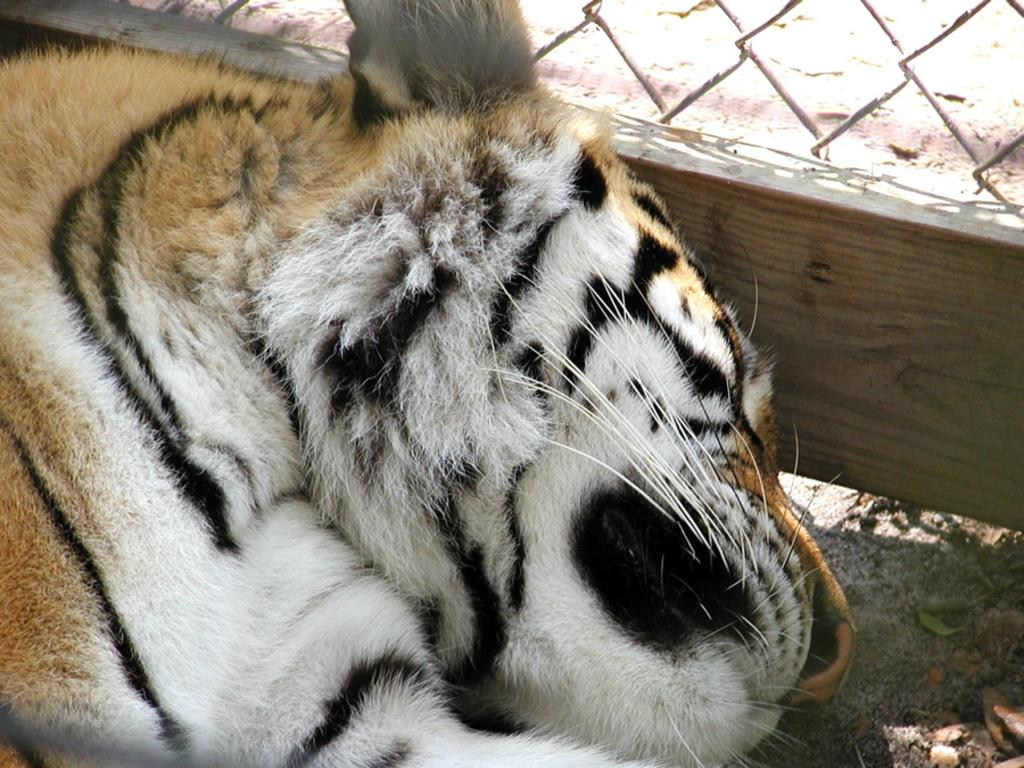What animal can be seen in the image? There is a tiger in the image. What is the tiger doing in the image? The tiger is sleeping on the ground. What can be seen in the background of the image? There is a mesh in the background of the image. What type of soup is being prepared in the image? There is no soup present in the image; it features a tiger sleeping on the ground with a mesh background. 